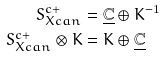<formula> <loc_0><loc_0><loc_500><loc_500>S _ { X c a n } ^ { c + } & = \underline { \mathbb { C } } \oplus K ^ { - 1 } \\ S _ { X c a n } ^ { c + } \otimes K & = K \oplus \underline { \mathbb { C } }</formula> 